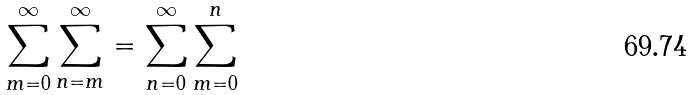<formula> <loc_0><loc_0><loc_500><loc_500>\sum ^ { \infty } _ { m = 0 } \sum ^ { \infty } _ { n = m } = \sum ^ { \infty } _ { n = 0 } \sum ^ { n } _ { m = 0 }</formula> 